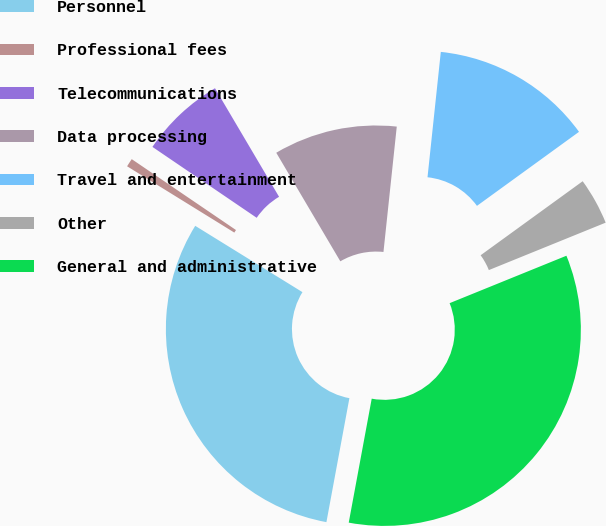Convert chart to OTSL. <chart><loc_0><loc_0><loc_500><loc_500><pie_chart><fcel>Personnel<fcel>Professional fees<fcel>Telecommunications<fcel>Data processing<fcel>Travel and entertainment<fcel>Other<fcel>General and administrative<nl><fcel>30.9%<fcel>0.69%<fcel>7.01%<fcel>10.17%<fcel>13.33%<fcel>3.85%<fcel>34.06%<nl></chart> 